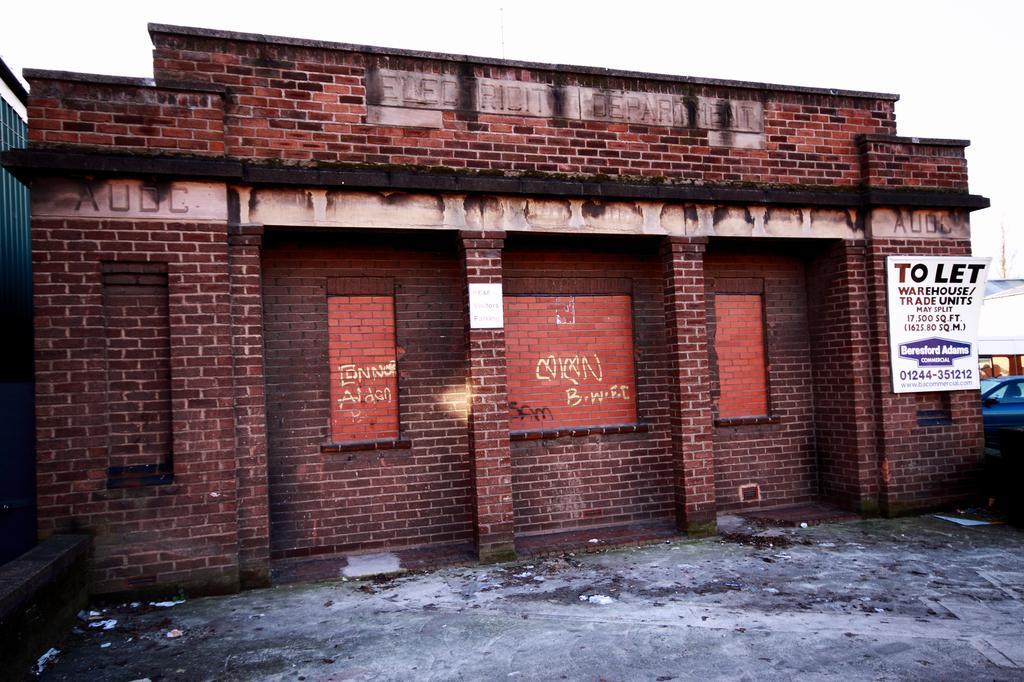Could you give a brief overview of what you see in this image? In this image there is a building and there is a board with some text written on it. On the right side there is a car. On the left side there is an object which is green in colour. 